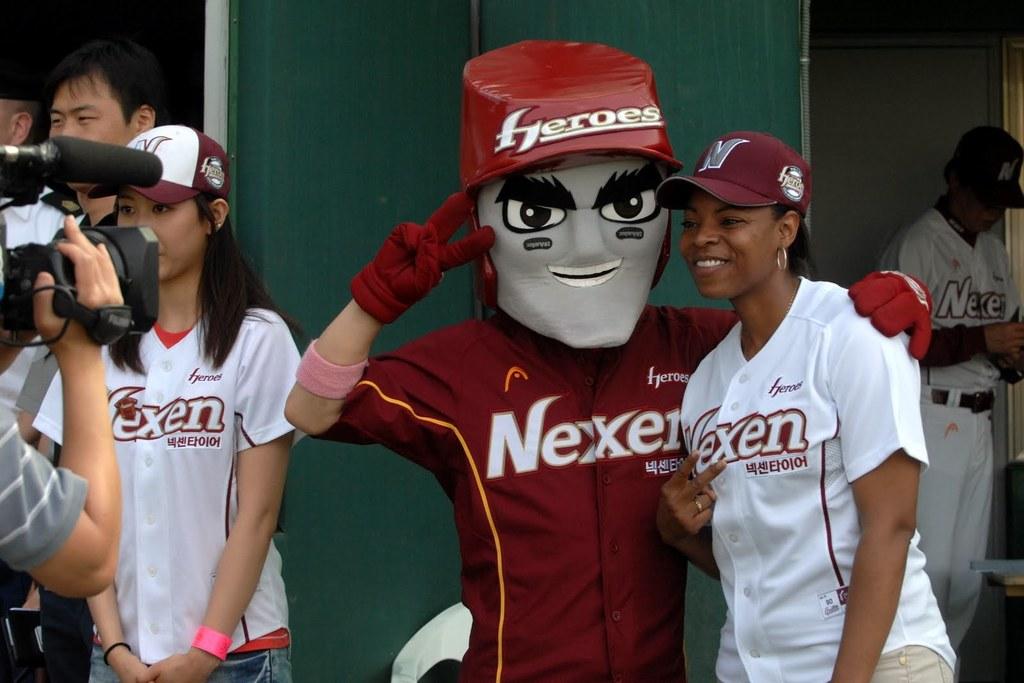What's the name of this team?
Provide a succinct answer. Nexen. What is printed on the mascot's helmet?
Your answer should be compact. Heroes. 